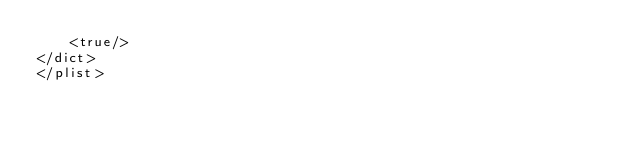<code> <loc_0><loc_0><loc_500><loc_500><_XML_>	<true/>
</dict>
</plist>
</code> 